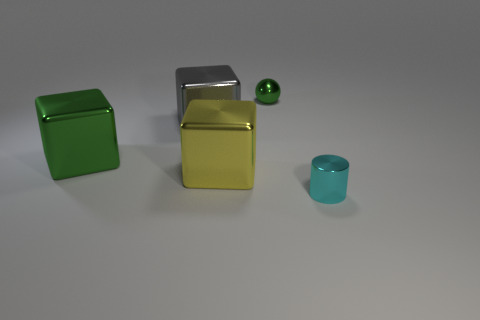Subtract all green blocks. How many blocks are left? 2 Add 5 small matte cubes. How many small matte cubes exist? 5 Add 2 small gray metal cylinders. How many objects exist? 7 Subtract 1 green spheres. How many objects are left? 4 Subtract all spheres. How many objects are left? 4 Subtract all green blocks. Subtract all brown cylinders. How many blocks are left? 2 Subtract all gray cylinders. How many yellow cubes are left? 1 Subtract all yellow things. Subtract all big green objects. How many objects are left? 3 Add 5 green metal things. How many green metal things are left? 7 